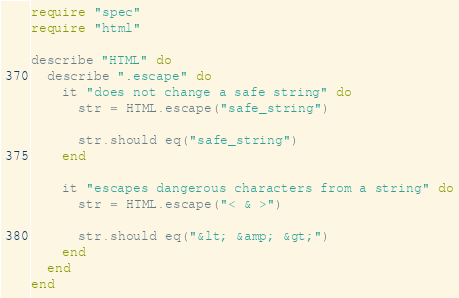<code> <loc_0><loc_0><loc_500><loc_500><_Crystal_>require "spec"
require "html"

describe "HTML" do
  describe ".escape" do
    it "does not change a safe string" do
      str = HTML.escape("safe_string")

      str.should eq("safe_string")
    end

    it "escapes dangerous characters from a string" do
      str = HTML.escape("< & >")

      str.should eq("&lt; &amp; &gt;")
    end
  end
end
</code> 